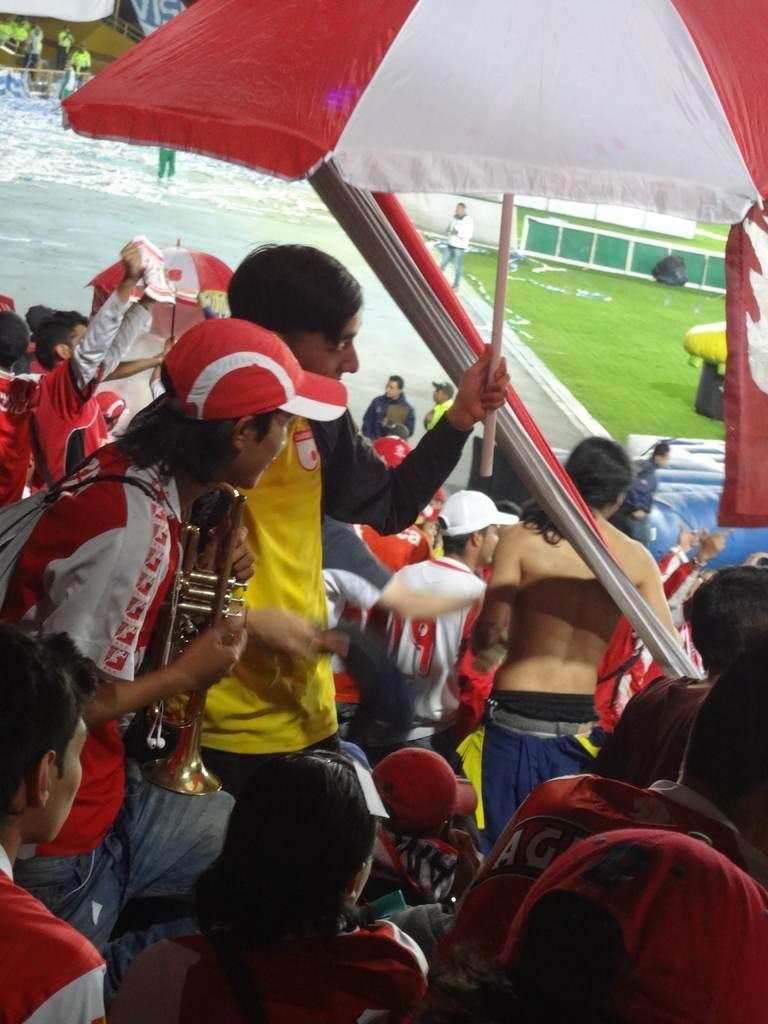Could you give a brief overview of what you see in this image? In this picture there are people in the center of the image and there is water in the top left side of the image, there is grassland on the right side of the image and there is an umbrella at the top side of the image. 